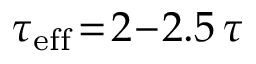Convert formula to latex. <formula><loc_0><loc_0><loc_500><loc_500>\tau _ { e f f } \, = \, 2 \, - \, 2 . 5 \, \tau</formula> 